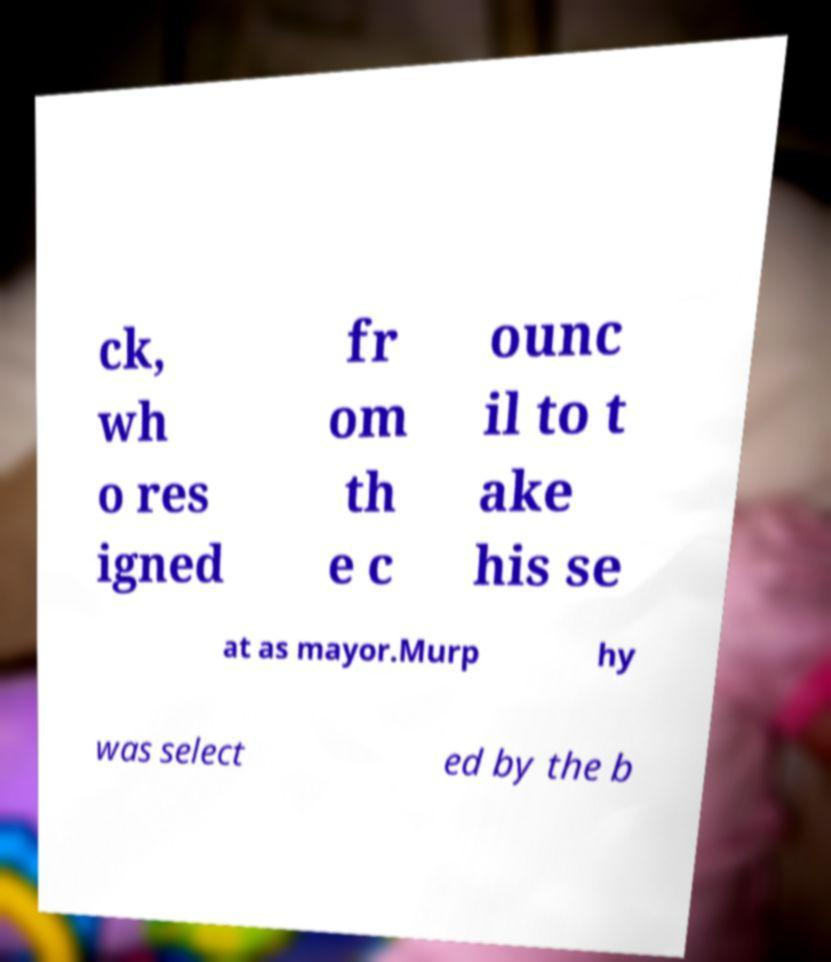Can you accurately transcribe the text from the provided image for me? ck, wh o res igned fr om th e c ounc il to t ake his se at as mayor.Murp hy was select ed by the b 